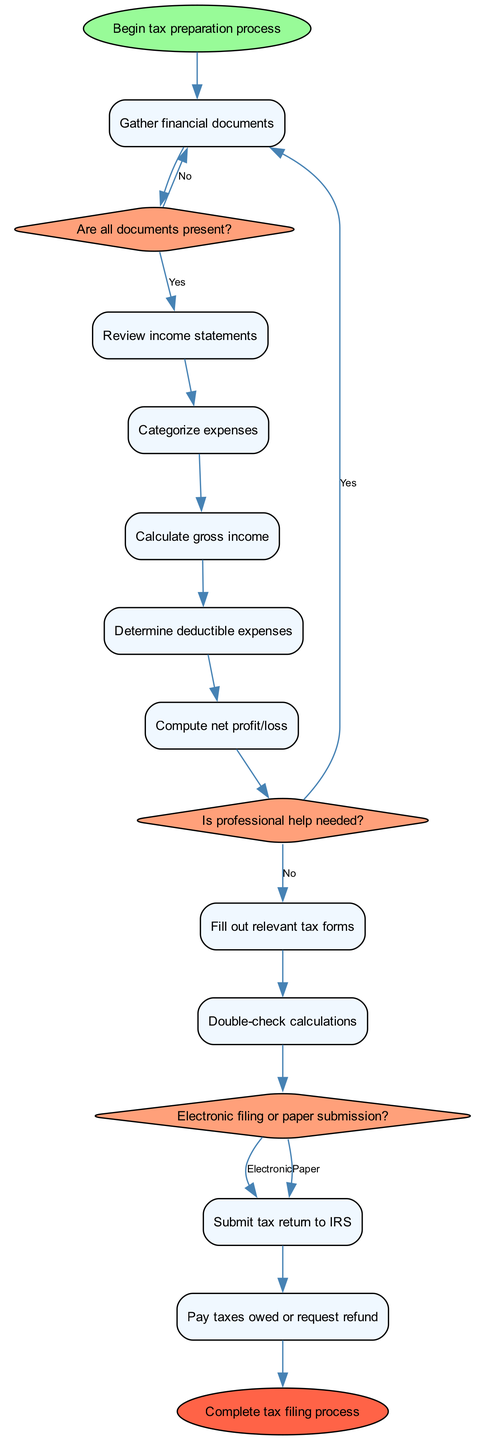What is the starting point of the process? The diagram begins with the "Begin tax preparation process" node, indicating the initial step in the workflow.
Answer: Begin tax preparation process How many activities are there in total? There are ten listed activities in the diagram, starting from "Gather financial documents" to "Pay taxes owed or request refund."
Answer: 10 What decision is made right after gathering financial documents? The first decision made is "Are all documents present?" after the activity of gathering financial documents.
Answer: Are all documents present? If the answer to the first decision is "No," which activity is repeated? If "No," the diagram shows a flow back to "Gather financial documents," indicating that this step must be repeated until all documents are present.
Answer: Gather financial documents What activity follows the determination of deductible expenses? After completing the "Determine deductible expenses" activity, the next step is to "Compute net profit/loss."
Answer: Compute net profit/loss How does the flow proceed if professional help is needed? If "Yes" is answered to the decision "Is professional help needed?", the flow returns to "Gather financial documents," signifying the need to assemble documents again, likely for the professional's review.
Answer: Gather financial documents What are the two options for submitting the tax return? The diagram indicates two options: "Electronic" and "Paper" submission for filing the tax return.
Answer: Electronic, Paper After submitting the tax return, what is the final step? The final step in the process after submitting the tax return is "Pay taxes owed or request refund."
Answer: Pay taxes owed or request refund What color represents the decision nodes in the diagram? The decision nodes are filled with a light coral color, referred to in the diagram as '#FFA07A'.
Answer: Light coral How many edges connect the start node to the first activity? There is one edge that connects the "Begin tax preparation process" start node to the first activity, which is "Gather financial documents."
Answer: 1 